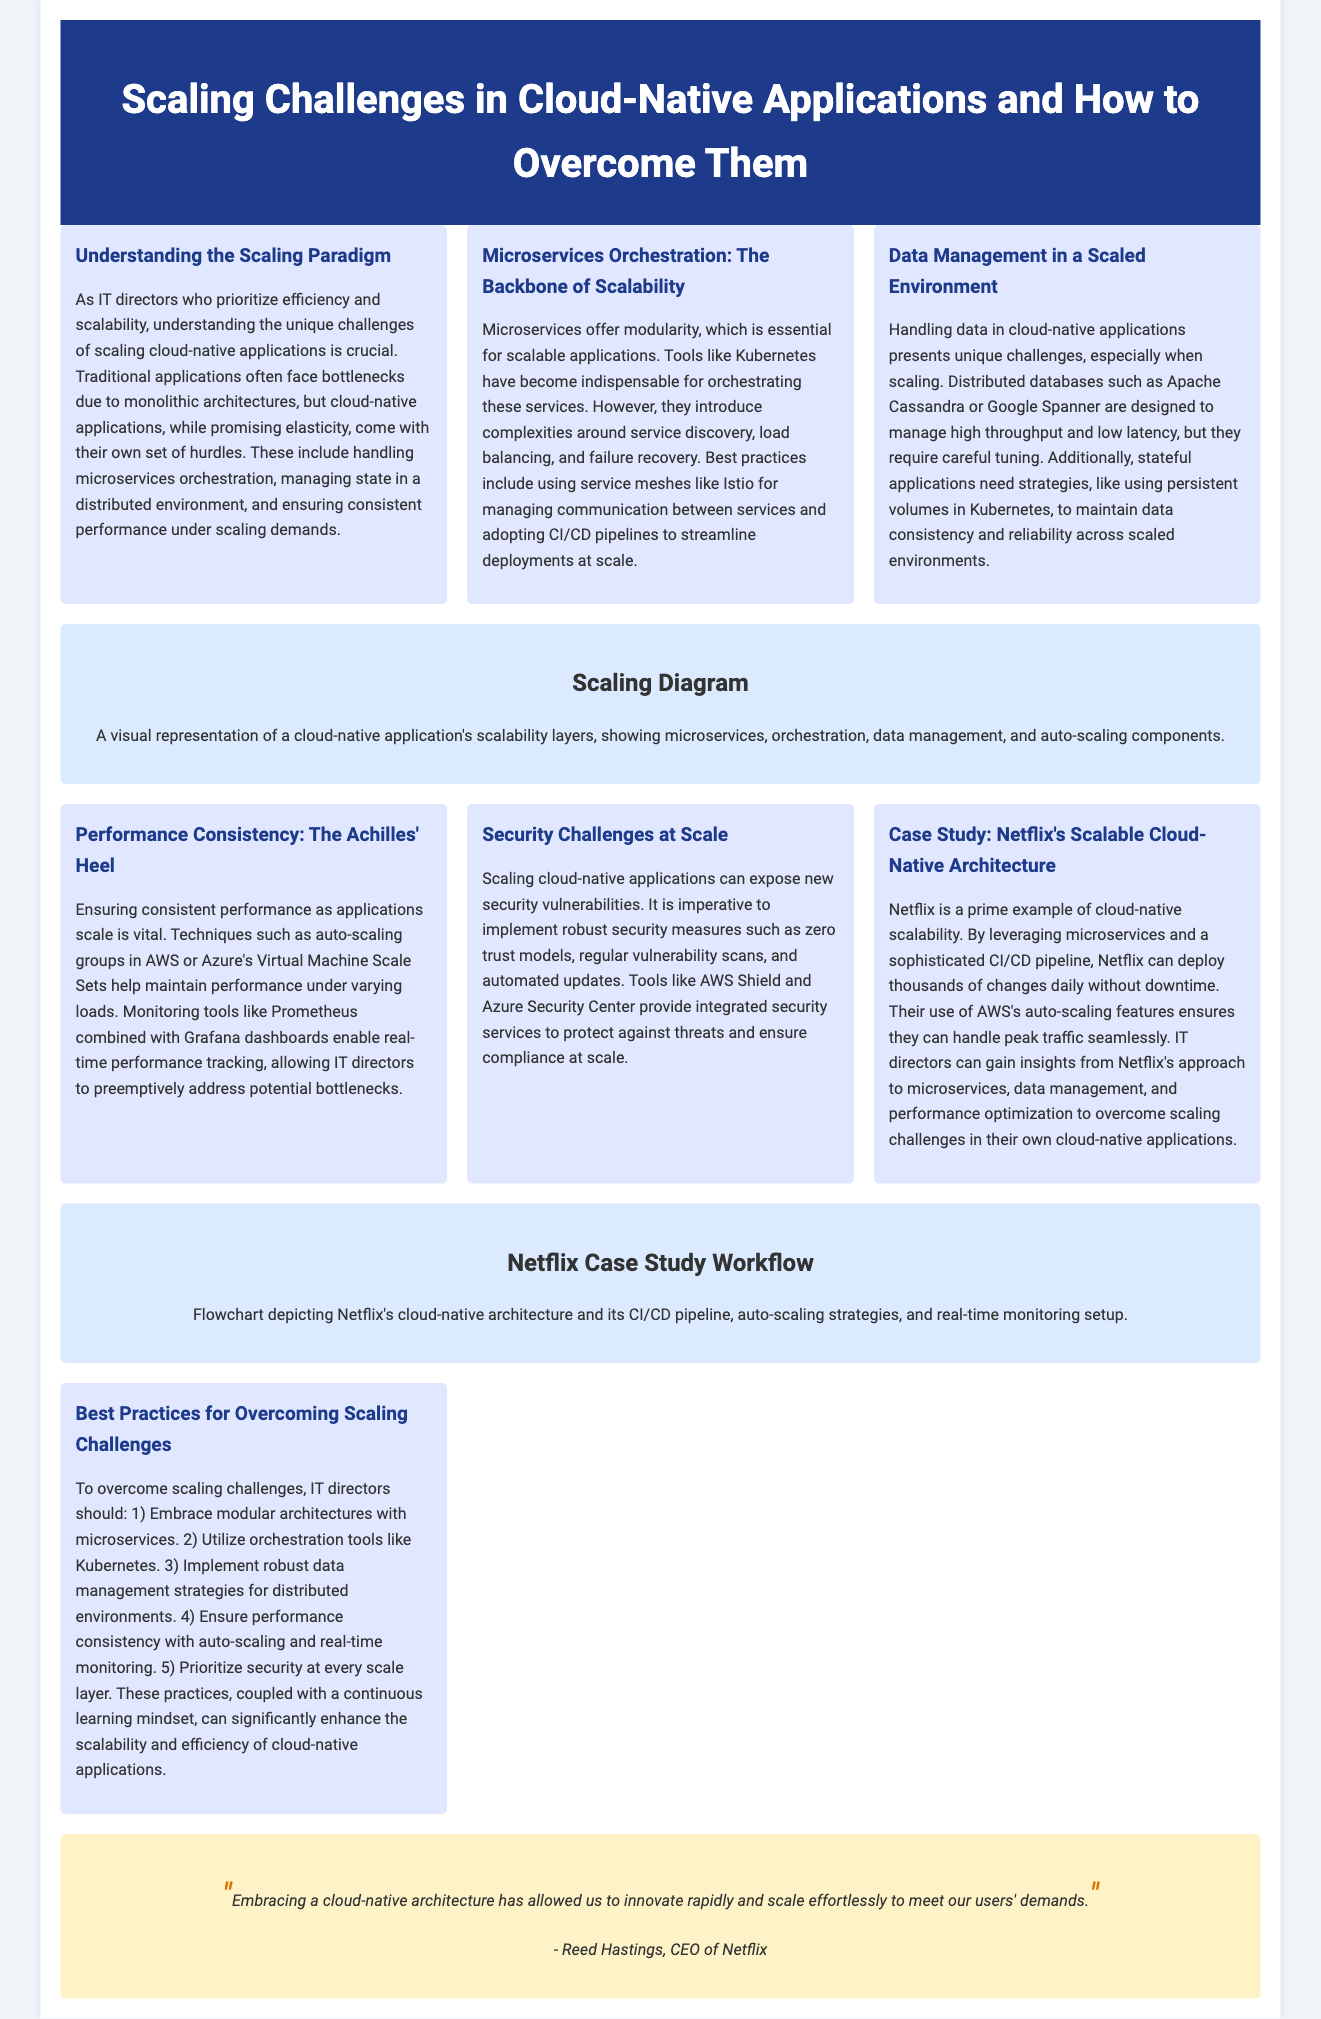What is the title of the document? The title of the document is found in the header section, which is prominently displayed.
Answer: Scaling Challenges in Cloud-Native Applications and How to Overcome Them Who is the CEO of Netflix? The document includes a quote by Reed Hastings, who is identified as the CEO of Netflix.
Answer: Reed Hastings What does the scaling diagram illustrate? The scaling diagram is an infographic that visually represents key aspects of cloud-native scalability.
Answer: A visual representation of a cloud-native application's scalability layers Which technology is essential for microservices orchestration? The document mentions Kubernetes as an indispensable tool for orchestrating microservices.
Answer: Kubernetes What is emphasized as a solution for performance consistency? The document suggests using auto-scaling groups as a technique to maintain performance under load.
Answer: Auto-scaling groups What is a key challenge mentioned regarding data management? The document highlights that handling data in cloud-native applications presents unique challenges, specifically when scaling.
Answer: Unique challenges How many strategies are listed for overcoming scaling challenges? The article provides a total of five strategies to overcome scaling challenges.
Answer: 5 What security model is recommended at scale? The document advises implementing zero trust models as a robust security measure for cloud-native applications.
Answer: Zero trust models What company is used as a case study? The document references Netflix to illustrate a successful cloud-native scalable architecture.
Answer: Netflix 